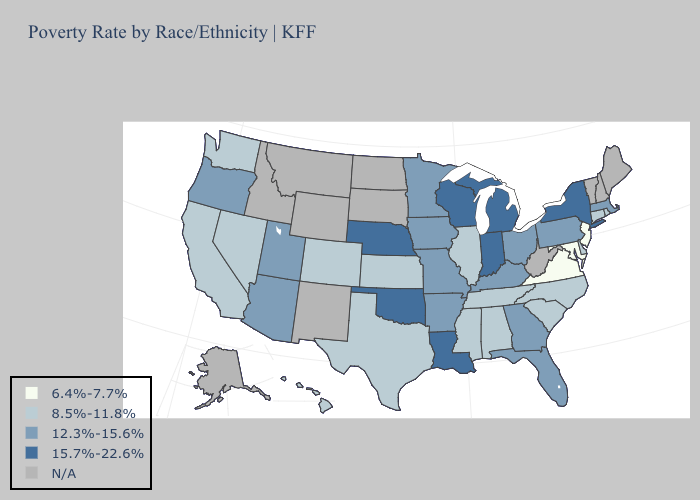Which states have the lowest value in the West?
Short answer required. California, Colorado, Hawaii, Nevada, Washington. Does Virginia have the lowest value in the South?
Keep it brief. Yes. What is the value of Minnesota?
Short answer required. 12.3%-15.6%. Name the states that have a value in the range 6.4%-7.7%?
Short answer required. Maryland, New Jersey, Virginia. What is the highest value in states that border Florida?
Keep it brief. 12.3%-15.6%. Which states hav the highest value in the Northeast?
Concise answer only. New York. What is the lowest value in the USA?
Answer briefly. 6.4%-7.7%. Among the states that border Nevada , which have the highest value?
Keep it brief. Arizona, Oregon, Utah. What is the value of Massachusetts?
Answer briefly. 12.3%-15.6%. What is the value of Utah?
Keep it brief. 12.3%-15.6%. What is the value of Montana?
Be succinct. N/A. Among the states that border Illinois , which have the lowest value?
Concise answer only. Iowa, Kentucky, Missouri. Which states have the lowest value in the Northeast?
Answer briefly. New Jersey. Among the states that border Texas , which have the highest value?
Short answer required. Louisiana, Oklahoma. 